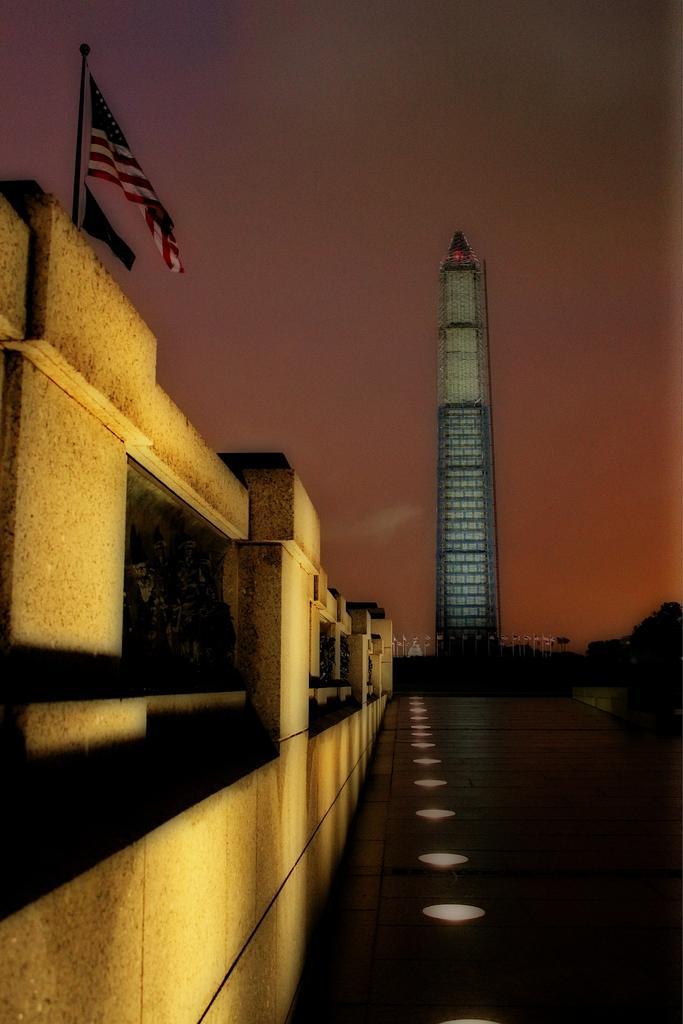In one or two sentences, can you explain what this image depicts? In this image there is one building at left side of this image and there is one tall building at right side of this image. There is one flag at top left side of this image and there is a sky at top of this image. 